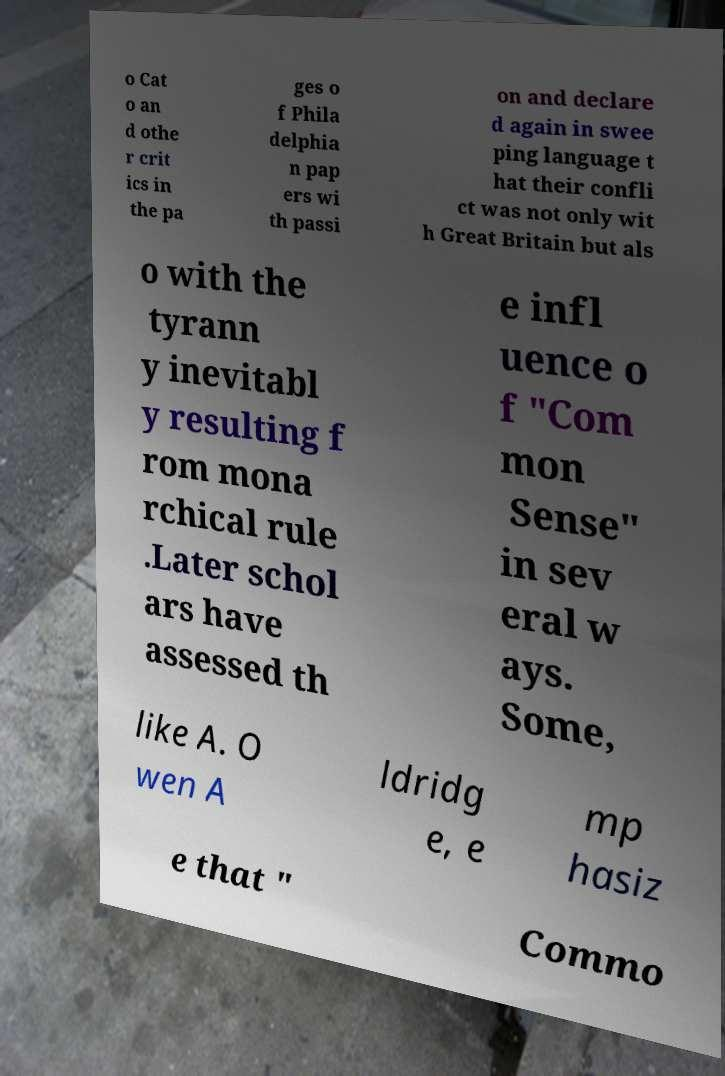Please read and relay the text visible in this image. What does it say? o Cat o an d othe r crit ics in the pa ges o f Phila delphia n pap ers wi th passi on and declare d again in swee ping language t hat their confli ct was not only wit h Great Britain but als o with the tyrann y inevitabl y resulting f rom mona rchical rule .Later schol ars have assessed th e infl uence o f "Com mon Sense" in sev eral w ays. Some, like A. O wen A ldridg e, e mp hasiz e that " Commo 